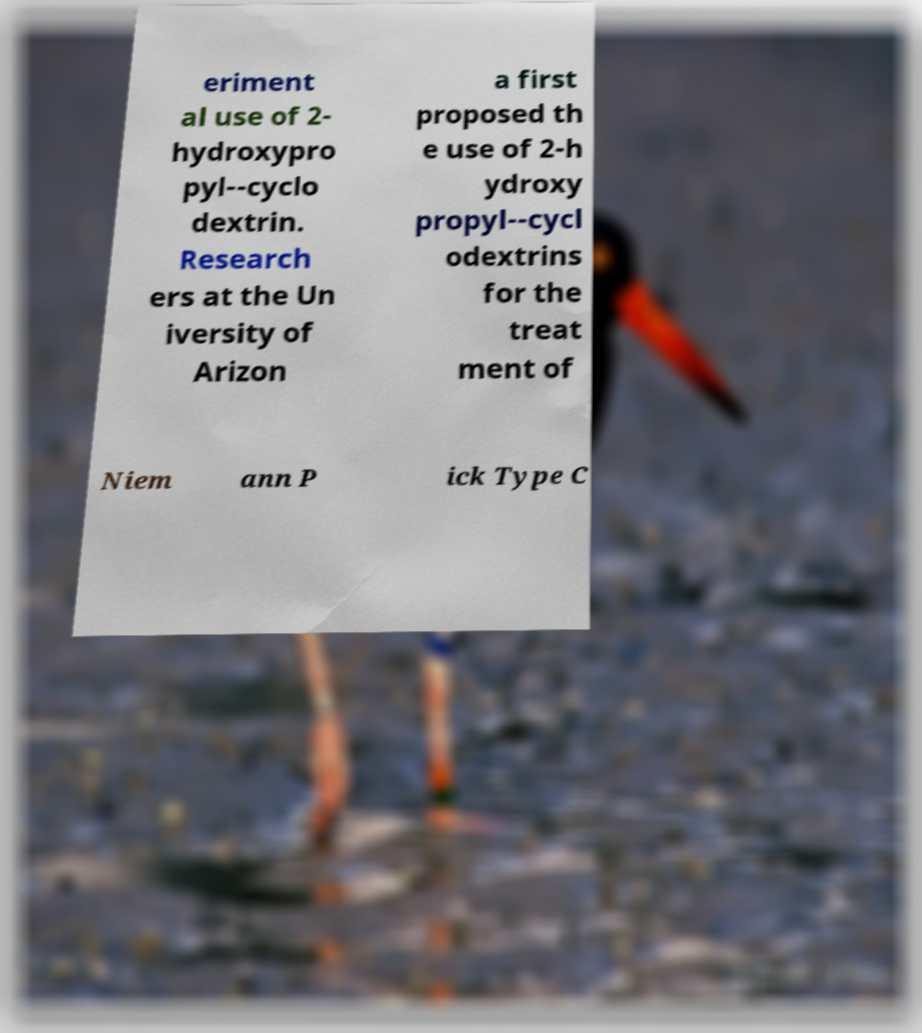Can you read and provide the text displayed in the image?This photo seems to have some interesting text. Can you extract and type it out for me? eriment al use of 2- hydroxypro pyl--cyclo dextrin. Research ers at the Un iversity of Arizon a first proposed th e use of 2-h ydroxy propyl--cycl odextrins for the treat ment of Niem ann P ick Type C 